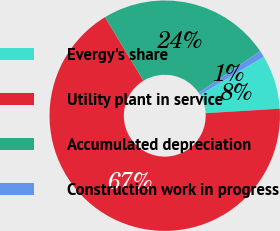Convert chart to OTSL. <chart><loc_0><loc_0><loc_500><loc_500><pie_chart><fcel>Evergy's share<fcel>Utility plant in service<fcel>Accumulated depreciation<fcel>Construction work in progress<nl><fcel>7.57%<fcel>67.28%<fcel>24.21%<fcel>0.93%<nl></chart> 